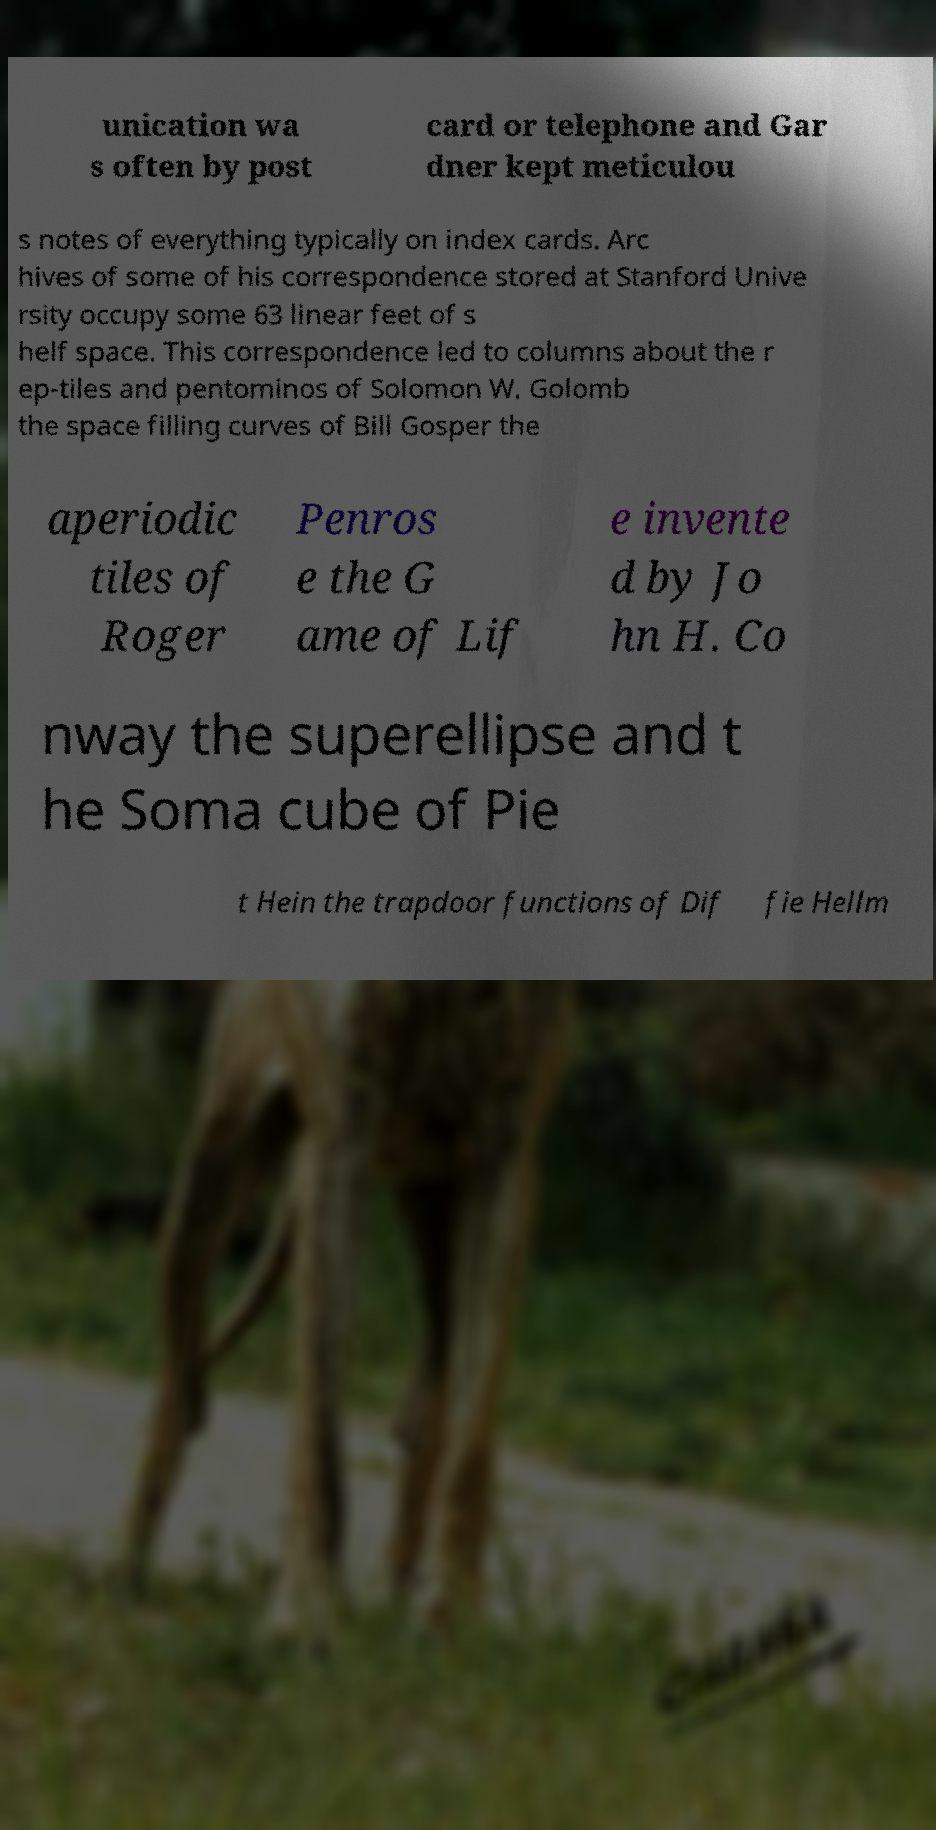Can you read and provide the text displayed in the image?This photo seems to have some interesting text. Can you extract and type it out for me? unication wa s often by post card or telephone and Gar dner kept meticulou s notes of everything typically on index cards. Arc hives of some of his correspondence stored at Stanford Unive rsity occupy some 63 linear feet of s helf space. This correspondence led to columns about the r ep-tiles and pentominos of Solomon W. Golomb the space filling curves of Bill Gosper the aperiodic tiles of Roger Penros e the G ame of Lif e invente d by Jo hn H. Co nway the superellipse and t he Soma cube of Pie t Hein the trapdoor functions of Dif fie Hellm 